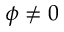<formula> <loc_0><loc_0><loc_500><loc_500>\phi \neq 0</formula> 